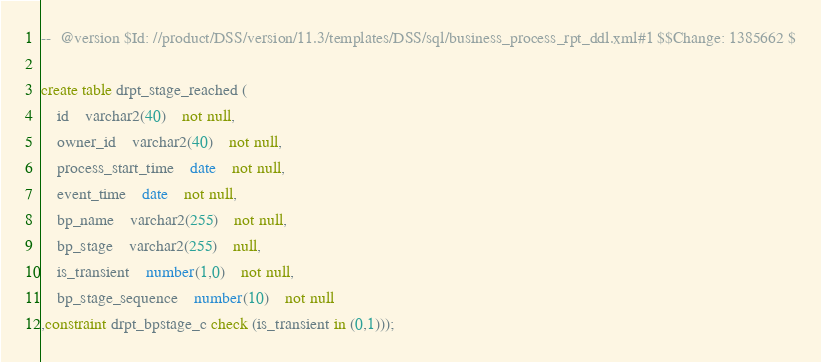Convert code to text. <code><loc_0><loc_0><loc_500><loc_500><_SQL_>

--  @version $Id: //product/DSS/version/11.3/templates/DSS/sql/business_process_rpt_ddl.xml#1 $$Change: 1385662 $

create table drpt_stage_reached (
	id	varchar2(40)	not null,
	owner_id	varchar2(40)	not null,
	process_start_time	date	not null,
	event_time	date	not null,
	bp_name	varchar2(255)	not null,
	bp_stage	varchar2(255)	null,
	is_transient	number(1,0)	not null,
	bp_stage_sequence	number(10)	not null
,constraint drpt_bpstage_c check (is_transient in (0,1)));




</code> 